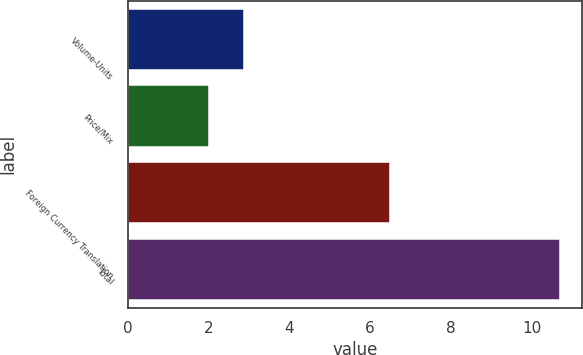Convert chart. <chart><loc_0><loc_0><loc_500><loc_500><bar_chart><fcel>Volume-Units<fcel>Price/Mix<fcel>Foreign Currency Translation<fcel>Total<nl><fcel>2.87<fcel>2<fcel>6.5<fcel>10.7<nl></chart> 